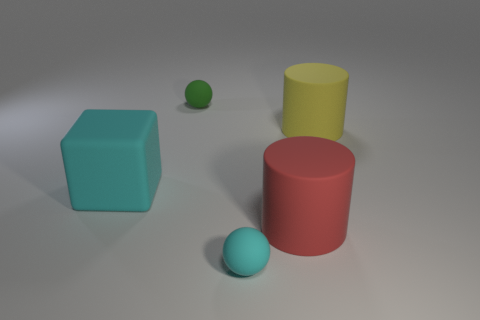Imagining this is a miniature set for a film, can you create a story around these objects? Certainly! In a realm where geometrical shapes have personalities, the big red cylinder is the village elder, known for his wisdom. The large yellow cube is the newcomer, bright and full of innovative ideas. The large turquoise cube is the trusty village square, where everyone gathers, and the tiny green ball is the village's playful child, rolling around and bringing joy to all the shapes. 